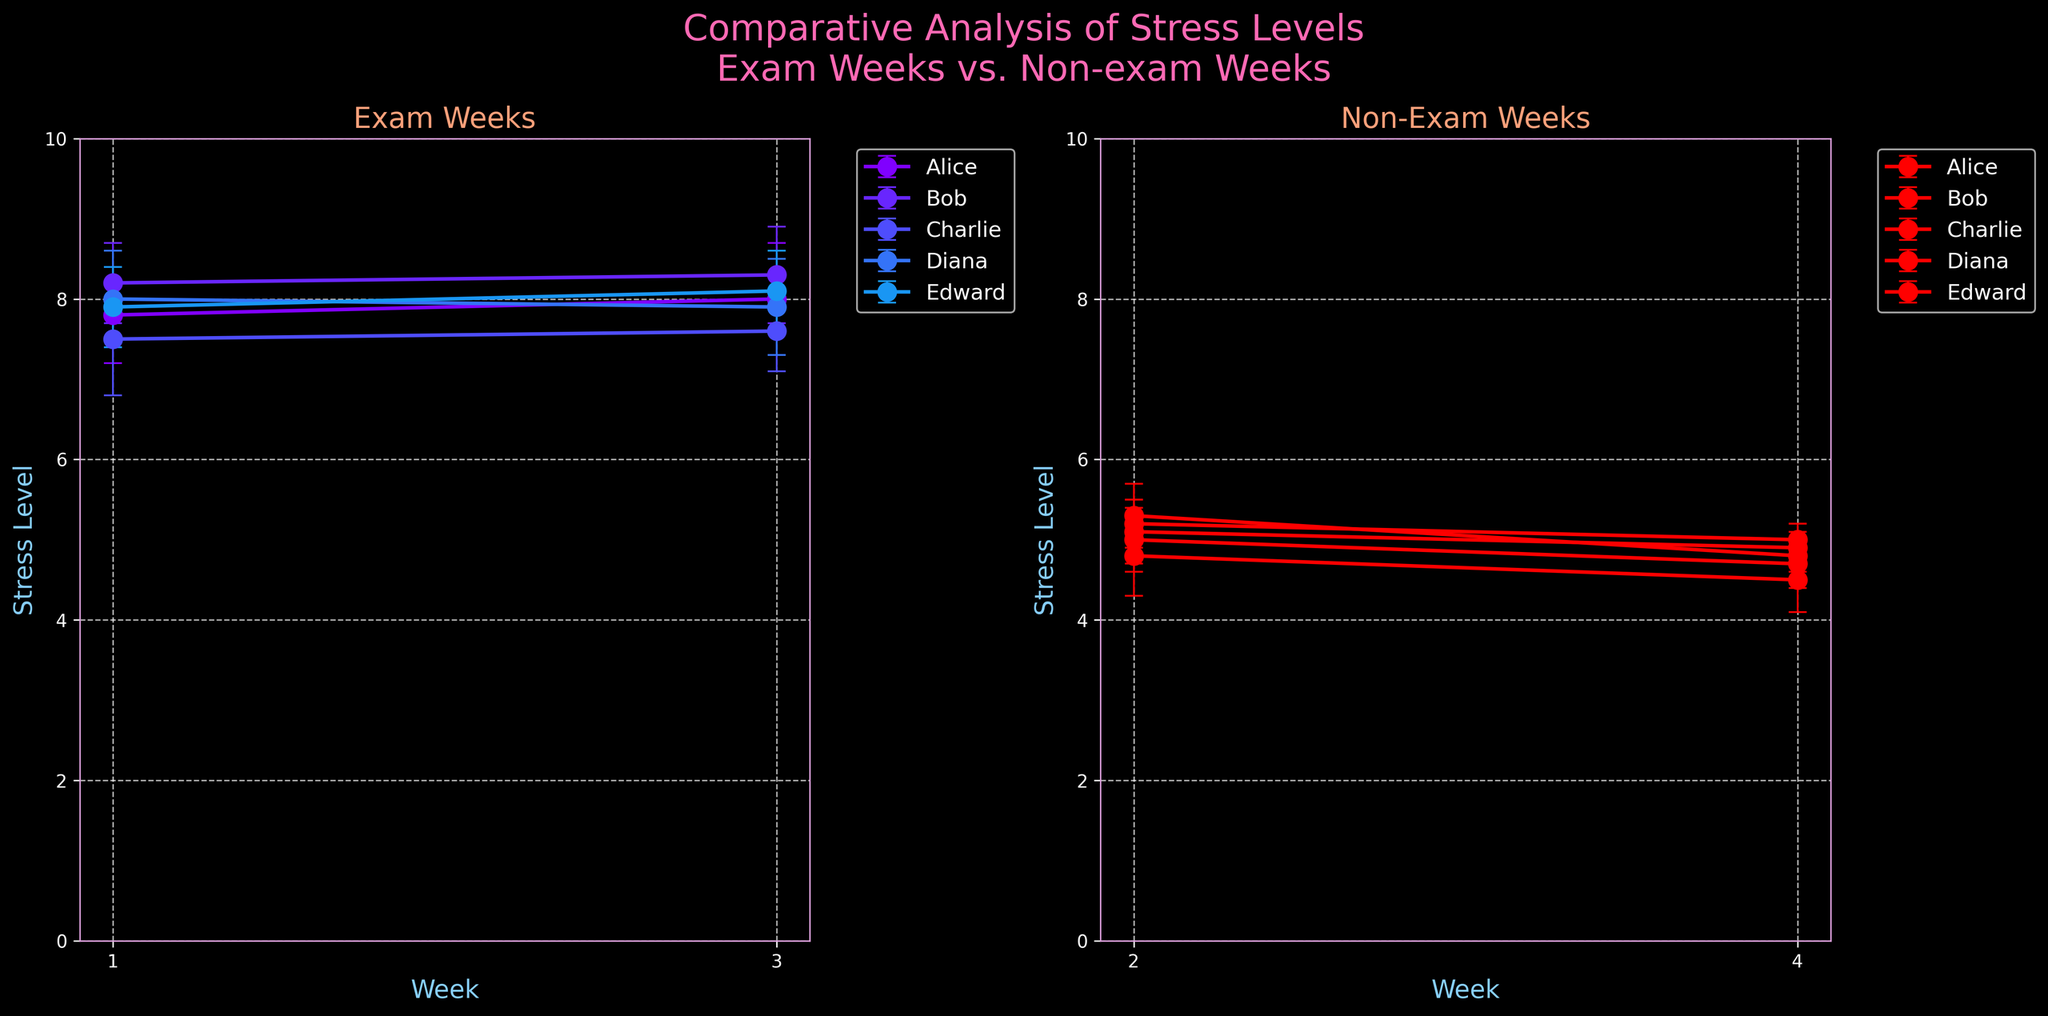What's the title of the plot? The title is located at the top center of the plot, and it is stated clearly.
Answer: "Comparative Analysis of Stress Levels\nExam Weeks vs. Non-exam Weeks" What are the conditions compared in the subplots? The titles on each of the two subplots indicate the conditions being compared.
Answer: Exam and Non-Exam Which subplot shows the stress levels during non-exam weeks? The subplot on the right side is labeled "Non-Exam Weeks," indicating stress levels during non-exam weeks.
Answer: The right subplot Give an example of a student with the highest stress level during exam weeks. By examining the stress levels for 'Exam' weeks, Bob has the highest level in both 'Week 1' (8.2) and 'Week 3' (8.3).
Answer: Bob How does Alice's stress level change from exam weeks to non-exam weeks? By comparing Alice's stress levels in exam weeks (average of 7.9) and non-exam weeks (average of 5.0), the stress level decreases significantly.
Answer: Decreases Which student shows the least fluctuation in stress levels during exam weeks? By examining the stress levels and the error bars, Edward (7.9 and 8.1) maintains similar levels with small error margins.
Answer: Edward What are the error bars representing in the plot? The error bars represent the uncertainty or variability in the stress level measurements for each student.
Answer: Uncertainty/variability Which week shows the lowest average stress level for non-exam weeks? By averaging the stress levels for each week, Week 4 with average stress levels of around 4.78 has the lowest value.
Answer: Week 4 Is there a clear difference in overall stress levels between exam and non-exam weeks? Comparing the two subplots, exam weeks show higher stress levels (average around 7.8) than non-exam weeks (average around 5.0).
Answer: Yes Which student displays the highest error margin during non-exam weeks? By examining the error bars on the 'Non-Exam' subplot, Diana has the highest error margin in Week 2 and Week 4.
Answer: Diana 